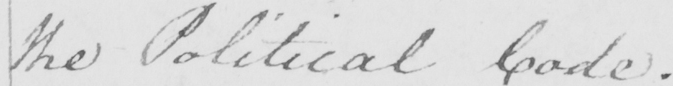Can you read and transcribe this handwriting? the Political Code . 